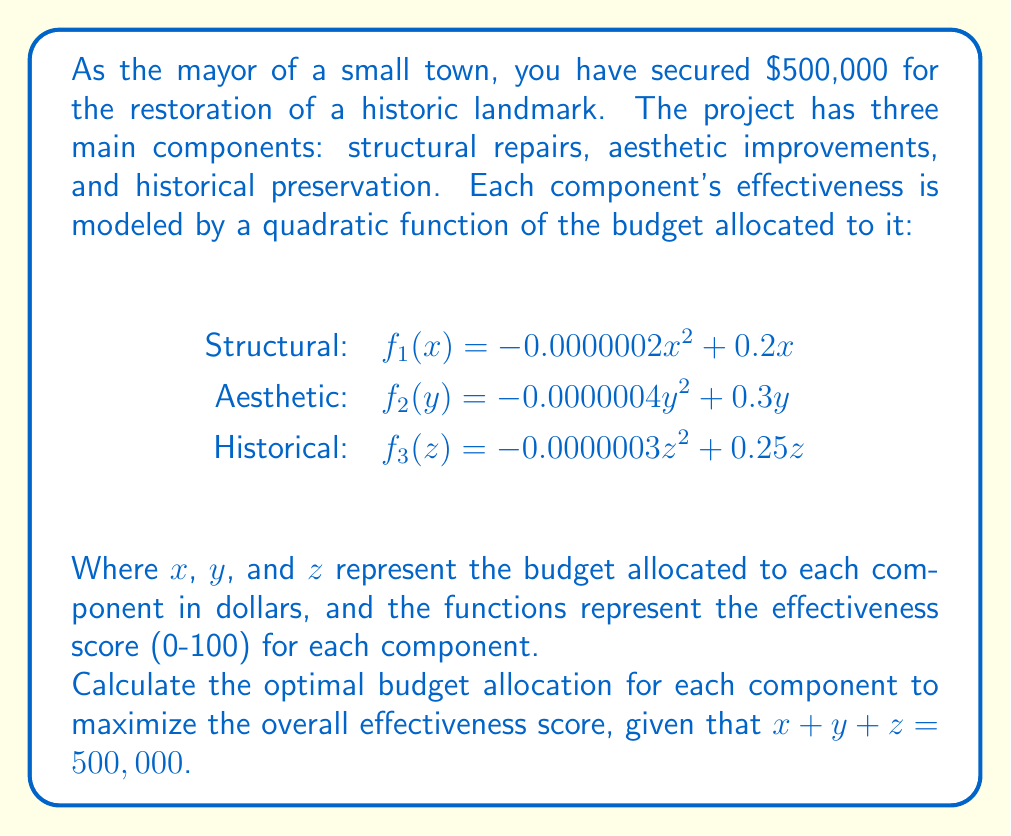Help me with this question. To solve this optimization problem, we can use the method of Lagrange multipliers. Let's define our objective function as the sum of the three effectiveness scores:

$$L = f_1(x) + f_2(y) + f_3(z) + \lambda(500000 - x - y - z)$$

Where $\lambda$ is the Lagrange multiplier. We need to find the partial derivatives of $L$ with respect to $x$, $y$, $z$, and $\lambda$, and set them equal to zero:

1) $\frac{\partial L}{\partial x} = -0.0000004x + 0.2 - \lambda = 0$
2) $\frac{\partial L}{\partial y} = -0.0000008y + 0.3 - \lambda = 0$
3) $\frac{\partial L}{\partial z} = -0.0000006z + 0.25 - \lambda = 0$
4) $\frac{\partial L}{\partial \lambda} = 500000 - x - y - z = 0$

From equations 1, 2, and 3:

5) $x = 500000 - 250000\lambda$
6) $y = 375000 - 125000\lambda$
7) $z = 416667 - 166667\lambda$

Substituting these into equation 4:

$500000 = (500000 - 250000\lambda) + (375000 - 125000\lambda) + (416667 - 166667\lambda)$

$500000 = 1291667 - 541667\lambda$

Solving for $\lambda$:

$\lambda = \frac{1291667 - 500000}{541667} \approx 1.46$

Now we can substitute this value back into equations 5, 6, and 7 to find the optimal allocations:

$x \approx 135000$
$y \approx 192500$
$z \approx 172500$

We can verify that these sum to 500,000 as required.
Answer: The optimal budget allocation is approximately:
Structural repairs: $135,000
Aesthetic improvements: $192,500
Historical preservation: $172,500 